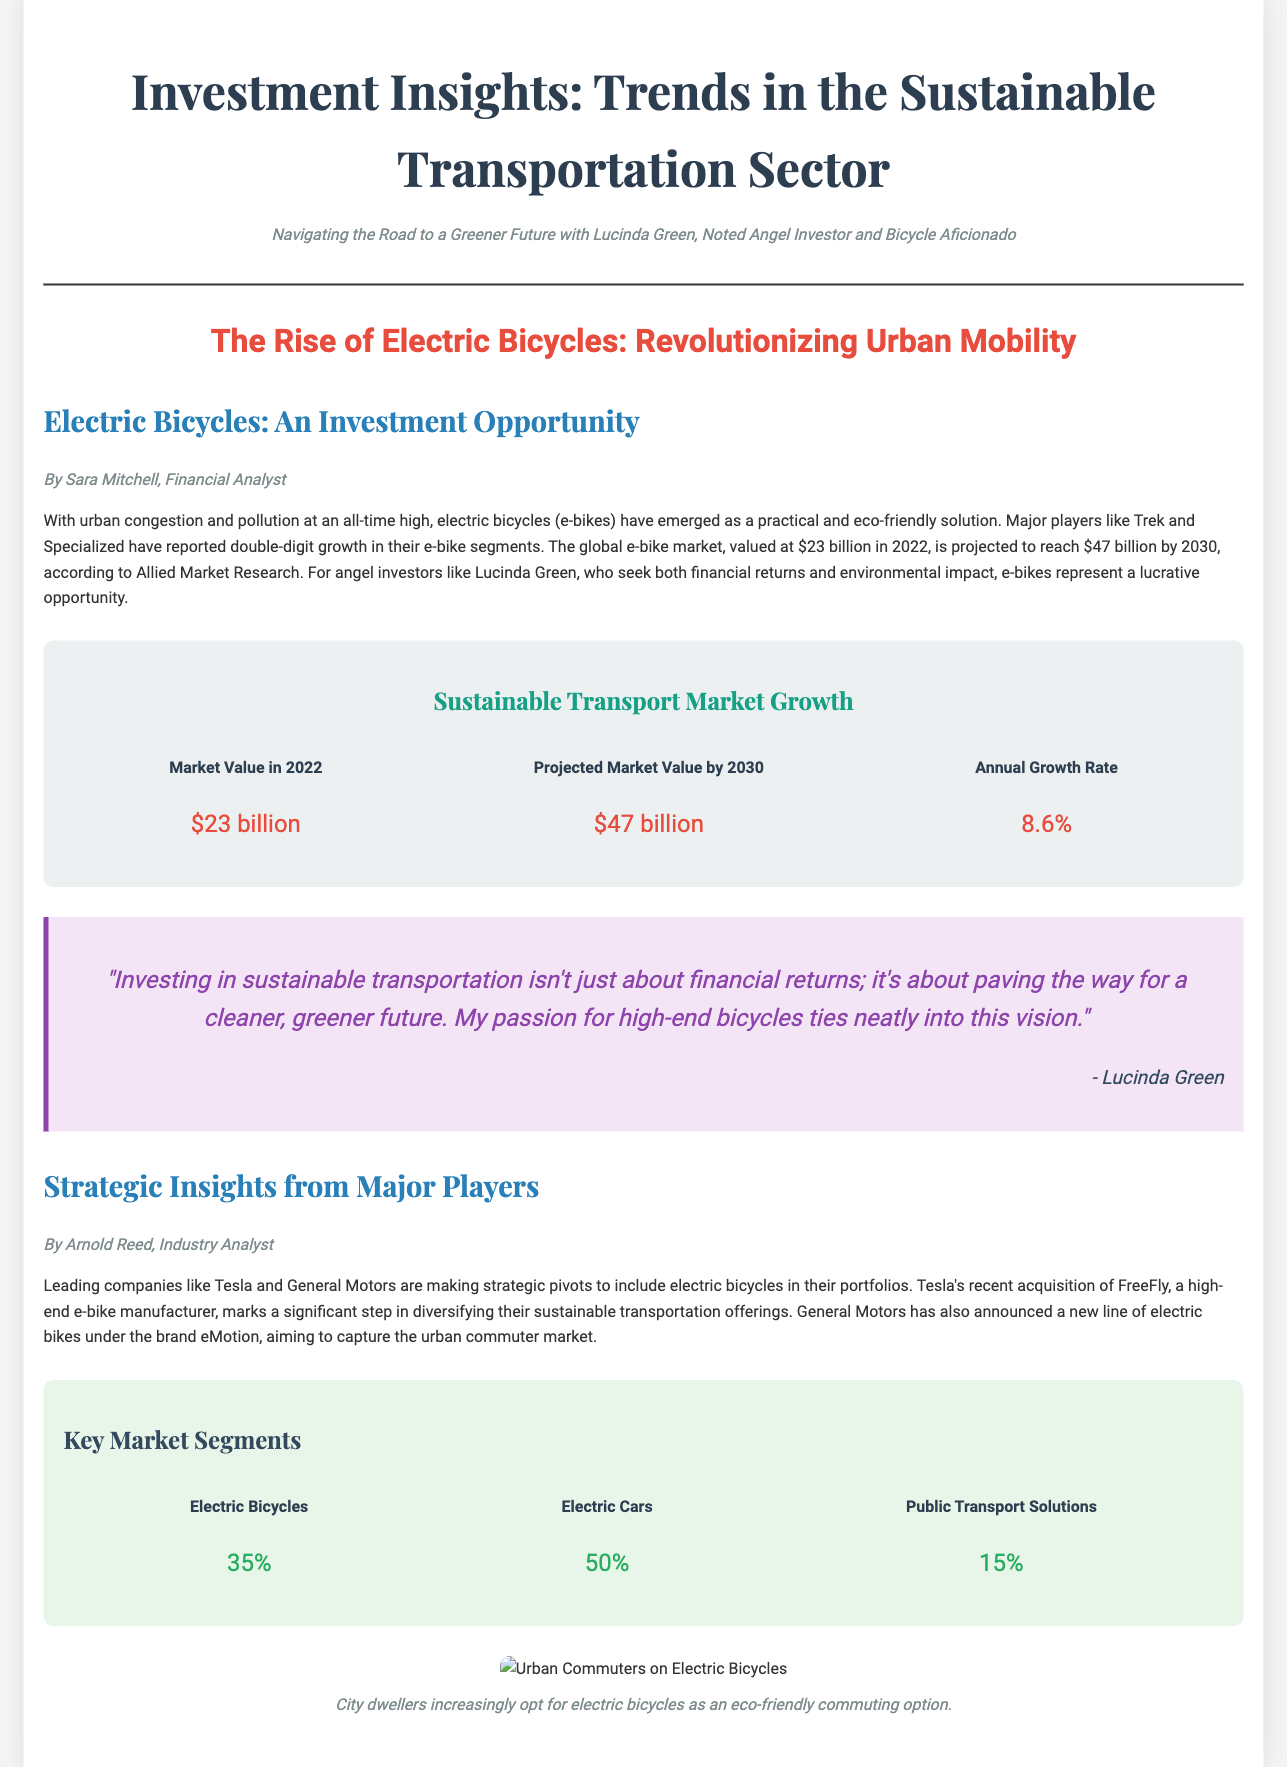What is the projected market value of e-bikes by 2030? The document states that the projected market value of e-bikes by 2030 is $47 billion.
Answer: $47 billion Who authored the article on Electric Bicycles as an investment opportunity? The author of the article is Sara Mitchell, as identified in the document.
Answer: Sara Mitchell What is the annual growth rate mentioned for the sustainable transport market? The annual growth rate for the sustainable transport market is stated as 8.6% in the infographic.
Answer: 8.6% Which major company recently acquired a high-end e-bike manufacturer? The document mentions that Tesla recently acquired FreeFly, a high-end e-bike manufacturer.
Answer: Tesla What percentage of the market do electric bicycles represent? According to the document, electric bicycles represent 35% of the market segments.
Answer: 35% What is the subtitle of the document focusing on sustainable transportation? The subtitle discusses the role of Lucinda Green, identified as a noted angel investor and bicycle aficionado.
Answer: Navigating the Road to a Greener Future with Lucinda Green, Noted Angel Investor and Bicycle Aficionado What color is used for the headline of the article? The headline color is indicated as #e74c3c, which is a shade of red.
Answer: #e74c3c What does Lucinda Green emphasize about investing in sustainable transportation? Lucinda Green emphasizes that investing in sustainable transportation is about paving the way for a cleaner, greener future.
Answer: A cleaner, greener future 